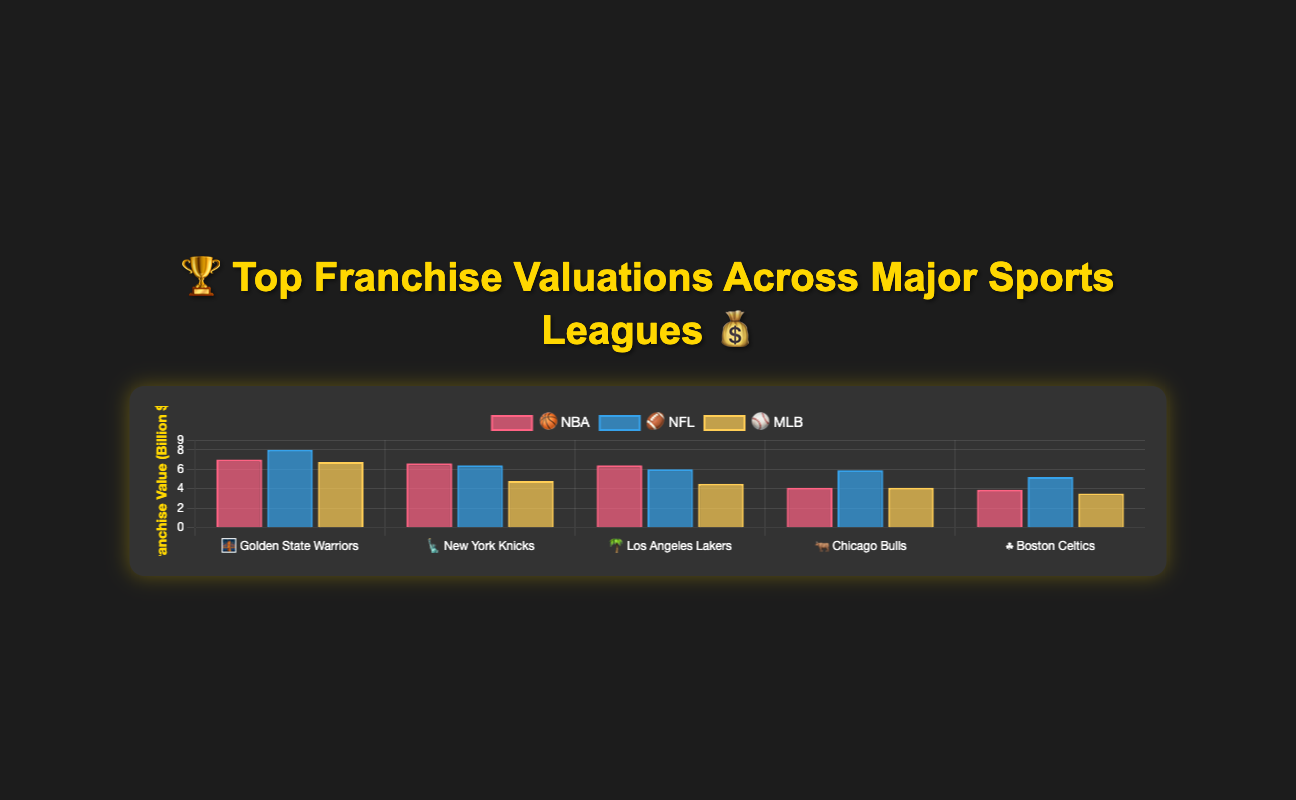Which NBA franchise has the highest valuation? The Golden State Warriors, represented by 🌉, have the highest valuation among NBA franchises, with a value of $7.0 billion. This can be identified from its position in the chart where it has the highest bar among NBA teams.
Answer: Golden State Warriors 🌉 What is the lowest-valued franchise in the MLB? Among the MLB franchises, the San Francisco Giants, represented by 🌫️, have the lowest valuation. They are placed last with a valuation of $3.5 billion, which is the smallest bar in the MLB dataset.
Answer: San Francisco Giants 🌫️ Compare the valuations of the New York Knicks and Dallas Cowboys. Which team is more valuable? The New York Knicks, represented by 🗽, have a valuation of $6.6 billion, while the Dallas Cowboys, represented by 🤠, have a valuation of $8.0 billion. Comparing these values, the Dallas Cowboys have a higher valuation.
Answer: Dallas Cowboys 🤠 What is the combined valuation of the Los Angeles Lakers and Boston Celtics? The Los Angeles Lakers (🌴) are valued at $6.4 billion, and the Boston Celtics (☘️) are valued at $3.9 billion. Adding these values together gives a combined valuation of $6.4B + $3.9B = $10.3 billion.
Answer: $10.3 billion Which league has the team with the highest valuation? The highest valued franchise across all leagues is the Dallas Cowboys (🤠) from the NFL, with a valuation of $8.0 billion.
Answer: NFL Determine the average valuation of the top 5 NBA franchises. The top 5 NBA franchises according to the chart are Golden State Warriors, New York Knicks, Los Angeles Lakers, Chicago Bulls, and Boston Celtics. Their valuations are $7.0B, $6.6B, $6.4B, $4.1B, and $3.9B respectively. The sum is $7.0 + $6.6 + $6.4 + $4.1 + $3.9 = $28.0 billion. Dividing by 5 gives us an average valuation of $28.0B / 5 = $5.6 billion.
Answer: $5.6 billion Which MLB team has a higher valuation: Boston Red Sox or Chicago Cubs? The Boston Red Sox (🧦) have a valuation of $4.5 billion, whereas the Chicago Cubs (🐻) have a valuation of $4.1 billion. Therefore, the Boston Red Sox have a higher valuation.
Answer: Boston Red Sox 🧦 What is the difference in valuation between the San Francisco 49ers and the New York Giants? The San Francisco 49ers (🌁) have a valuation of $5.2 billion, while the New York Giants (🏙️) have a valuation of $6.0 billion. The difference is $6.0B - $5.2B = $0.8 billion.
Answer: $0.8 billion Identify the franchise with the lowest value across all leagues. By scanning the chart for the smallest bars, we identify the San Francisco Giants (🌫️) from the MLB as the franchise with the lowest valuation at $3.5 billion.
Answer: San Francisco Giants 🌫️ 